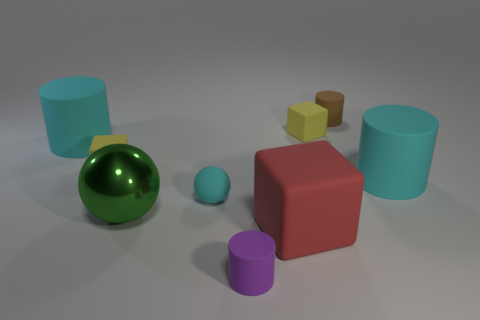Subtract 1 cylinders. How many cylinders are left? 3 Subtract all yellow cylinders. Subtract all cyan balls. How many cylinders are left? 4 Add 1 large green objects. How many objects exist? 10 Subtract all cylinders. How many objects are left? 5 Add 3 big blocks. How many big blocks exist? 4 Subtract 0 red balls. How many objects are left? 9 Subtract all green things. Subtract all small purple cylinders. How many objects are left? 7 Add 2 tiny yellow matte things. How many tiny yellow matte things are left? 4 